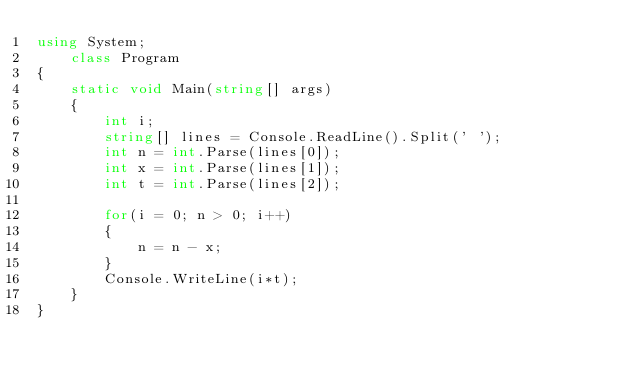<code> <loc_0><loc_0><loc_500><loc_500><_C#_>using System;
    class Program
{
    static void Main(string[] args)
    {
        int i;
        string[] lines = Console.ReadLine().Split(' ');
        int n = int.Parse(lines[0]);
        int x = int.Parse(lines[1]);
        int t = int.Parse(lines[2]);

        for(i = 0; n > 0; i++)
        {
            n = n - x;
        }
        Console.WriteLine(i*t);
    }
}</code> 